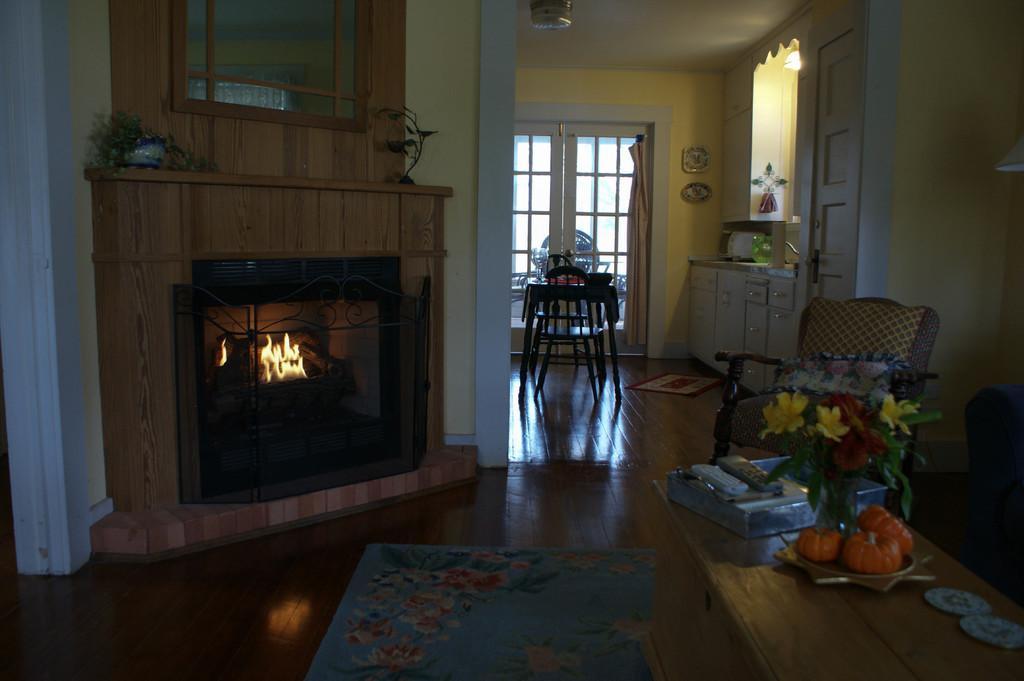In one or two sentences, can you explain what this image depicts? This picture is clicked inside the room. In the foreground we can see the floor mat and a wooden table on the top of which a flower vase, platter containing food items, box, remote and some objects are placed. On the left we can see the fire in a fireplace and we can see the potted plant and an object. On the right we can see a chair. In the background we can see the wall, doors, curtain, some objects hanging on the wall and we can see the table, chairs, cabinet containing some objects. At the top there is a roof and we can see light and some objects. 